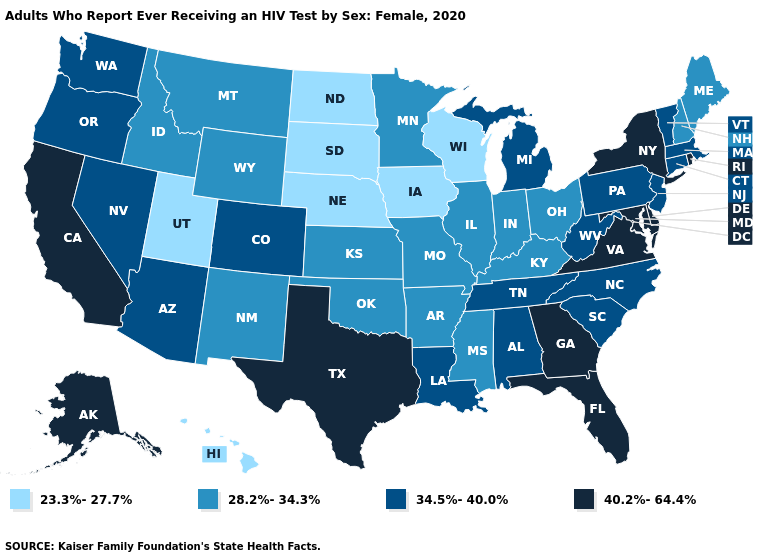Which states have the lowest value in the South?
Concise answer only. Arkansas, Kentucky, Mississippi, Oklahoma. Which states hav the highest value in the South?
Write a very short answer. Delaware, Florida, Georgia, Maryland, Texas, Virginia. What is the value of Hawaii?
Answer briefly. 23.3%-27.7%. What is the value of South Dakota?
Be succinct. 23.3%-27.7%. What is the value of Missouri?
Quick response, please. 28.2%-34.3%. What is the highest value in the MidWest ?
Short answer required. 34.5%-40.0%. Does the map have missing data?
Answer briefly. No. What is the highest value in the USA?
Be succinct. 40.2%-64.4%. Does Hawaii have the lowest value in the USA?
Keep it brief. Yes. Among the states that border Connecticut , does Rhode Island have the lowest value?
Give a very brief answer. No. Does the first symbol in the legend represent the smallest category?
Write a very short answer. Yes. Name the states that have a value in the range 34.5%-40.0%?
Short answer required. Alabama, Arizona, Colorado, Connecticut, Louisiana, Massachusetts, Michigan, Nevada, New Jersey, North Carolina, Oregon, Pennsylvania, South Carolina, Tennessee, Vermont, Washington, West Virginia. Among the states that border Vermont , does Massachusetts have the lowest value?
Answer briefly. No. Does the first symbol in the legend represent the smallest category?
Answer briefly. Yes. Is the legend a continuous bar?
Give a very brief answer. No. 